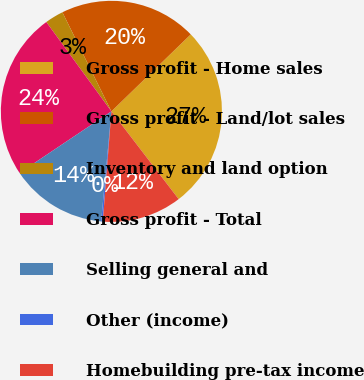<chart> <loc_0><loc_0><loc_500><loc_500><pie_chart><fcel>Gross profit - Home sales<fcel>Gross profit - Land/lot sales<fcel>Inventory and land option<fcel>Gross profit - Total<fcel>Selling general and<fcel>Other (income)<fcel>Homebuilding pre-tax income<nl><fcel>26.85%<fcel>20.05%<fcel>2.71%<fcel>24.38%<fcel>14.12%<fcel>0.24%<fcel>11.65%<nl></chart> 